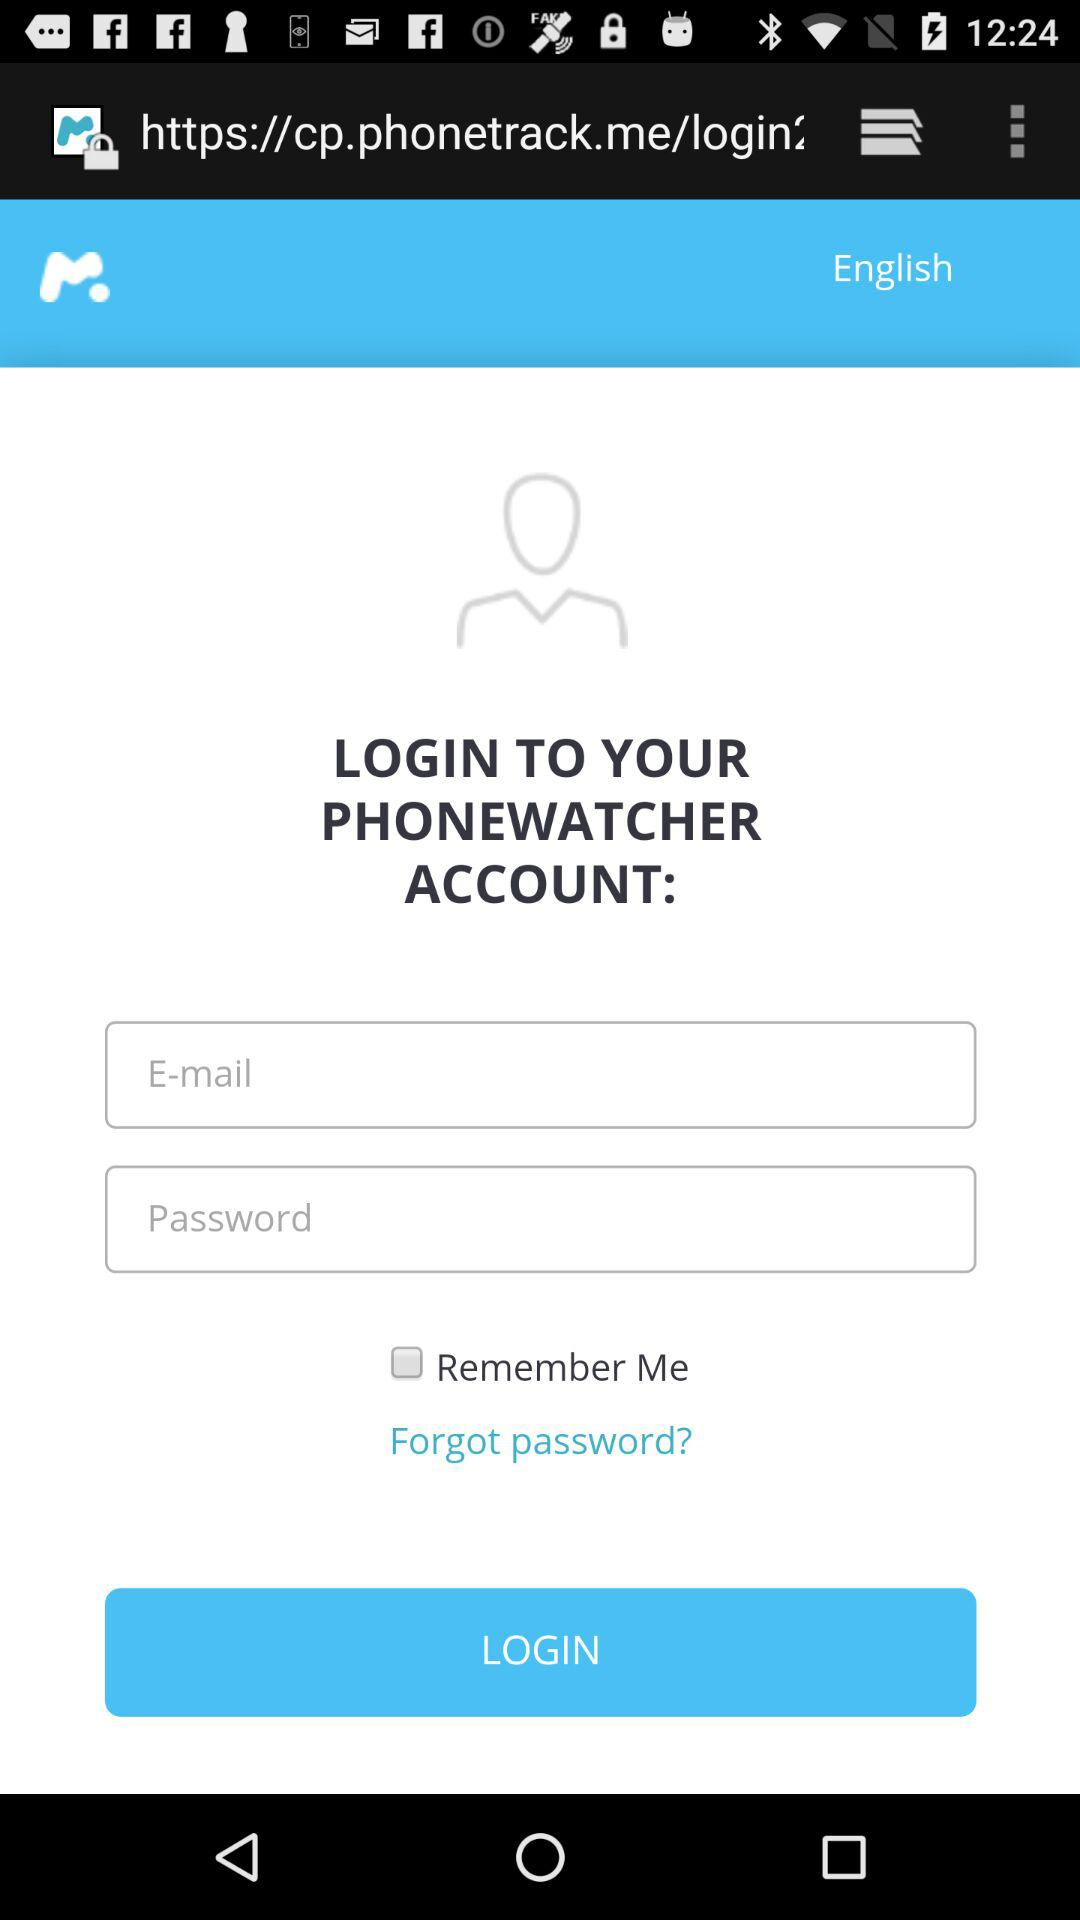What is the app name? The app name is "PHONEWATCHER". 